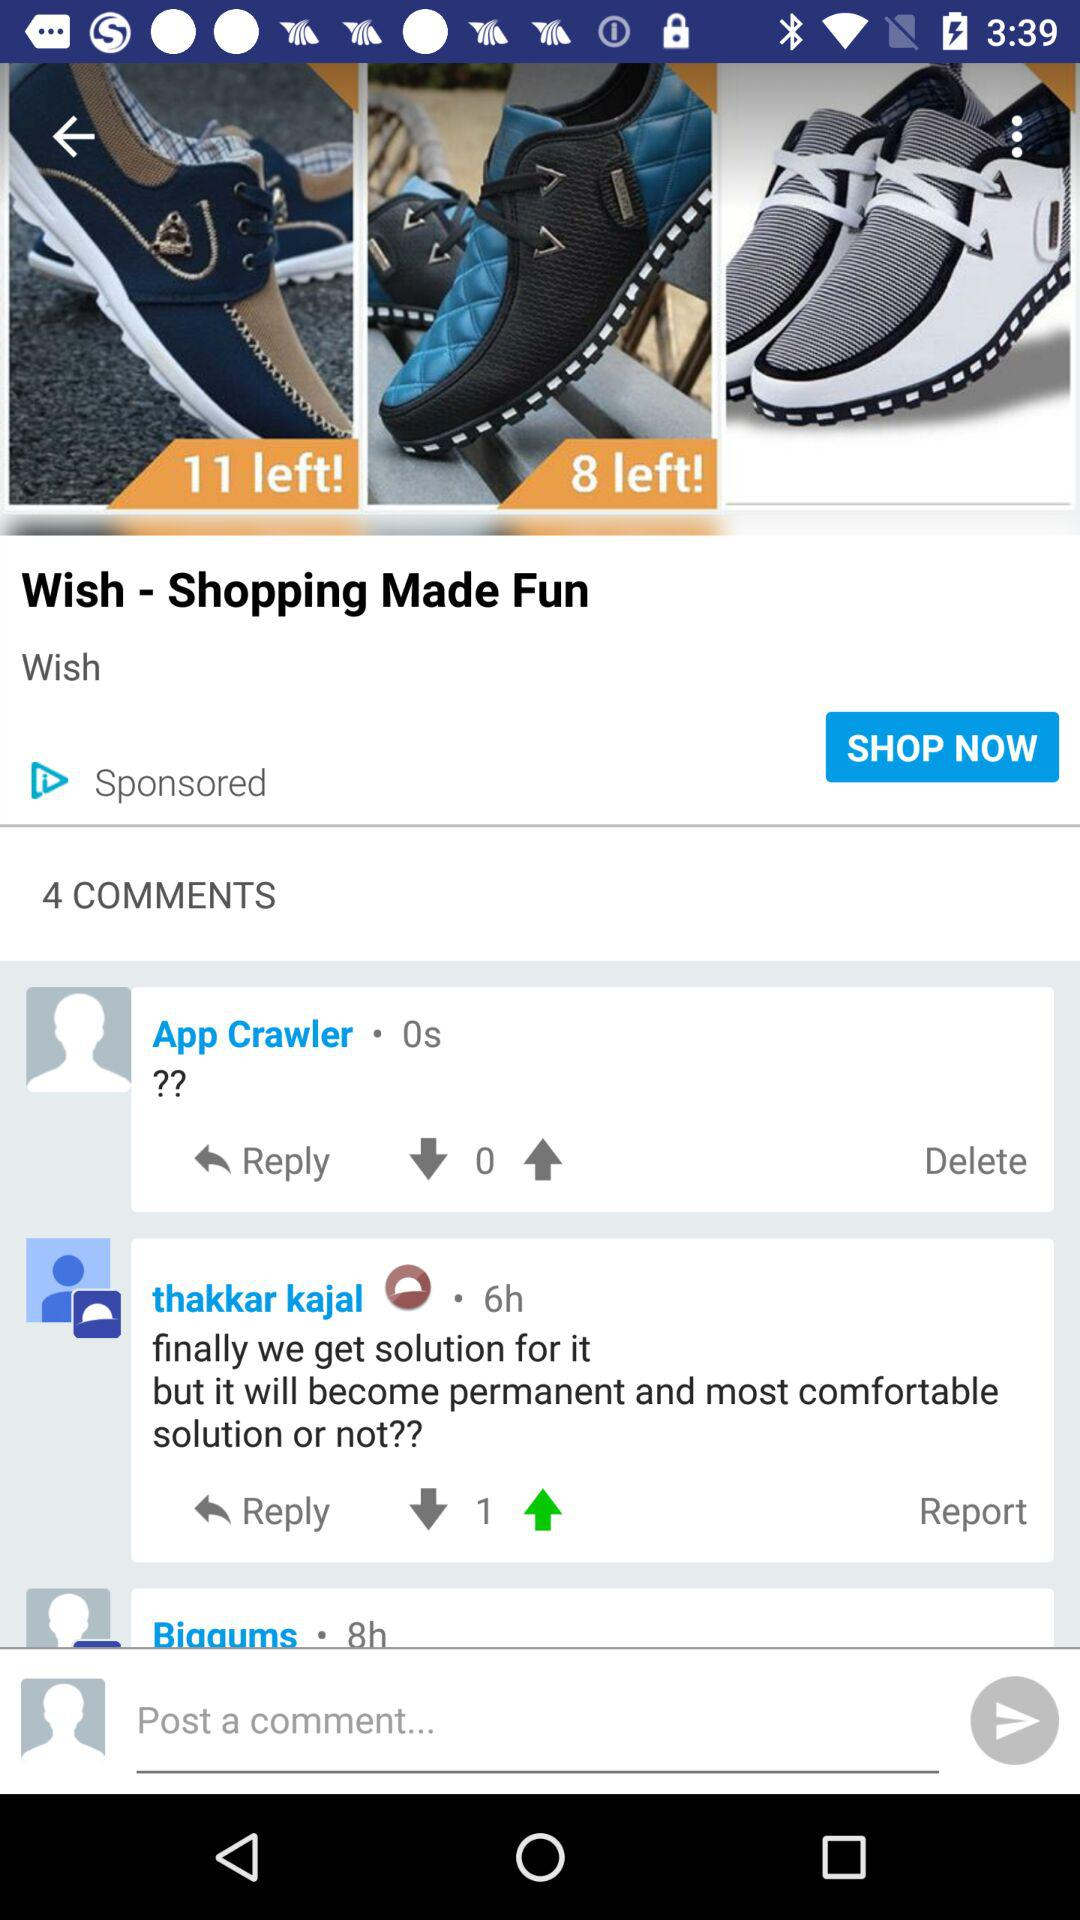How many comments are there? There are four comments. 